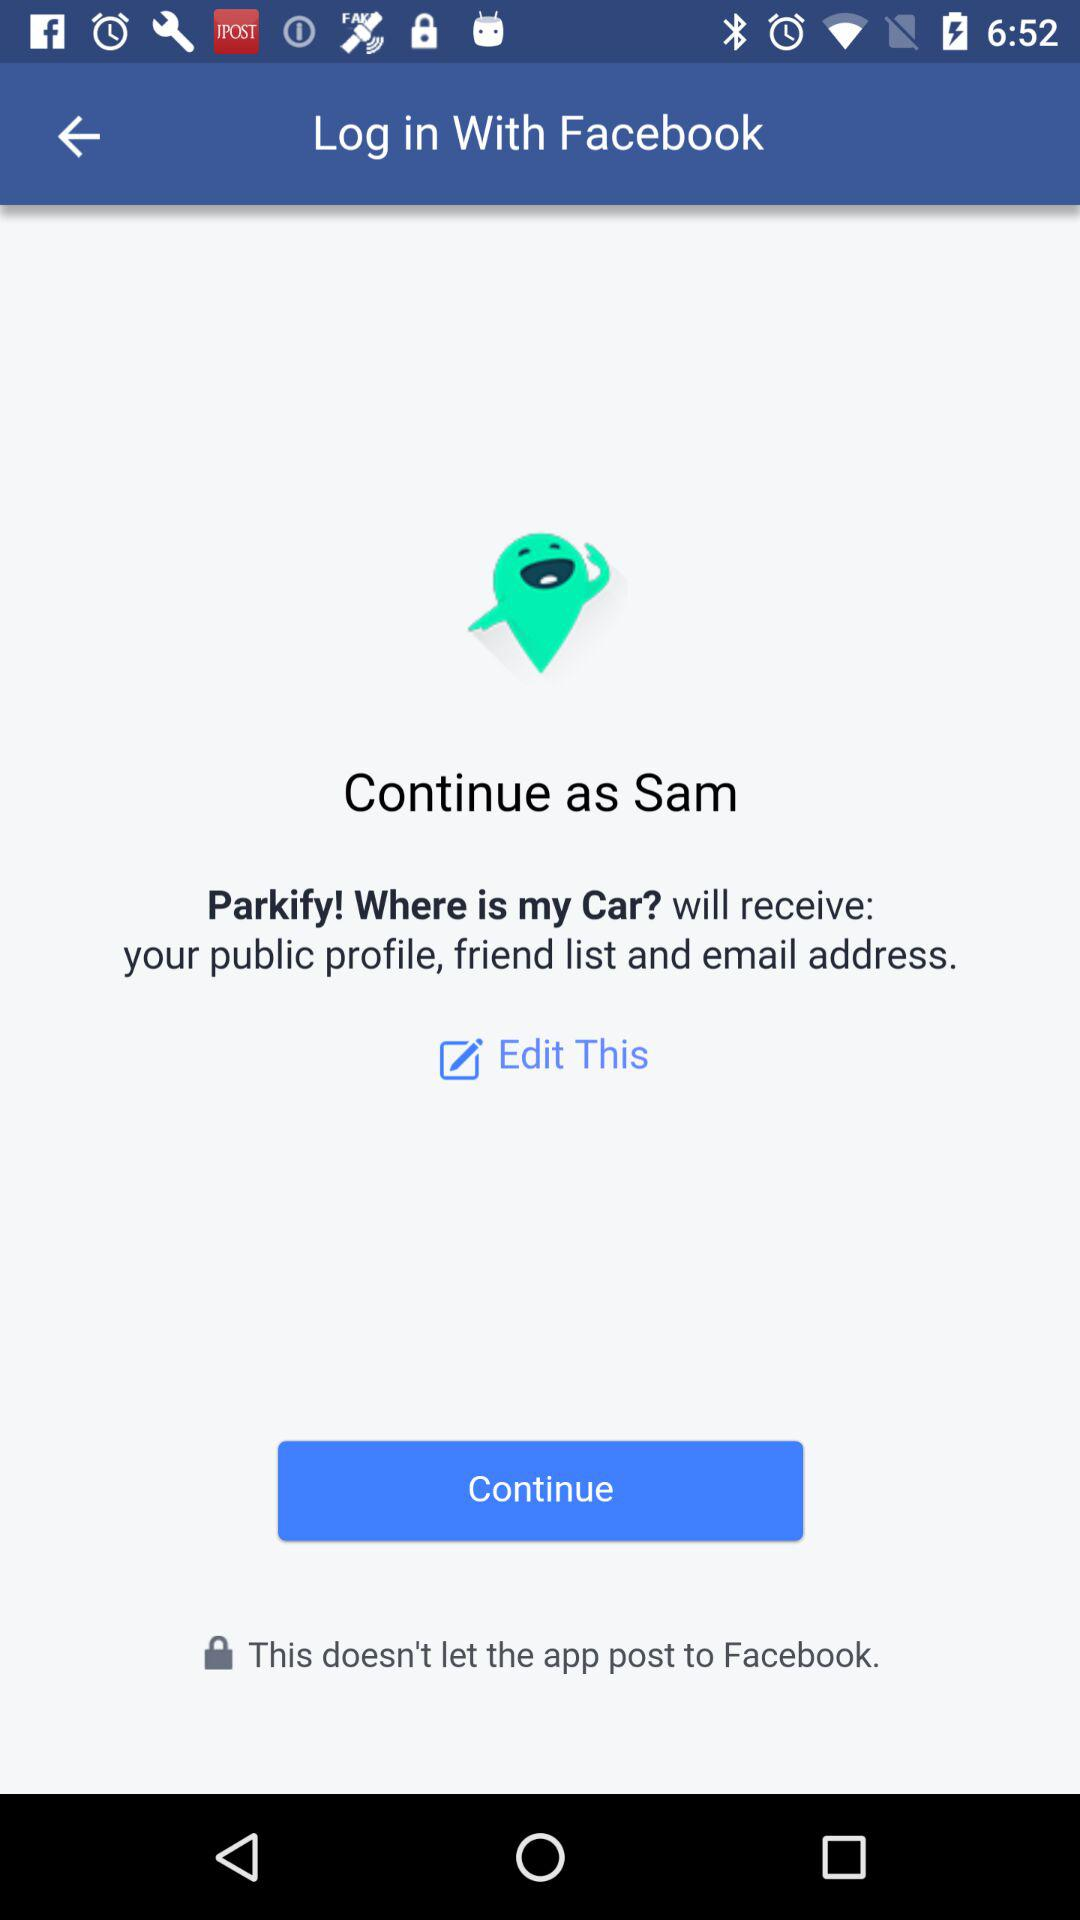When was the application last updated?
When the provided information is insufficient, respond with <no answer>. <no answer> 